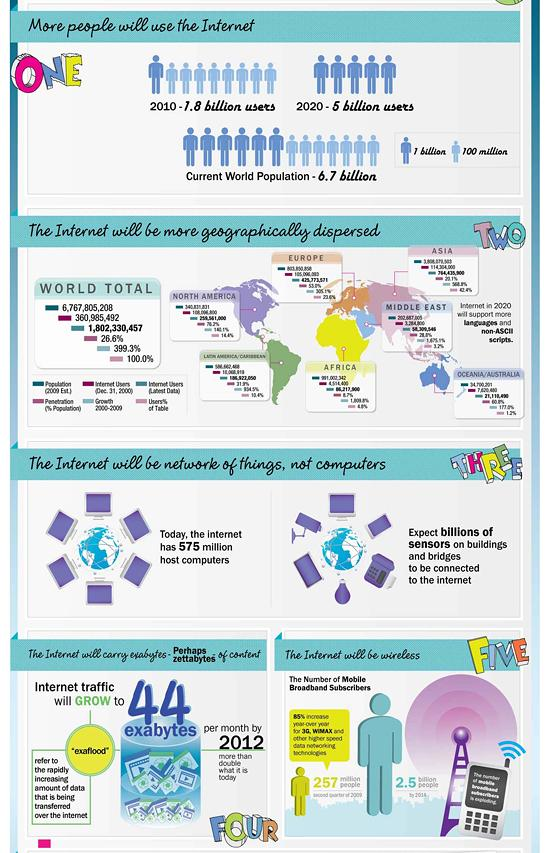Identify some key points in this picture. The last point mentioned about the internet is that it will be wireless. Approximately 1.7 billion people do not use the internet, representing a significant portion of the global population. The number of internet users in 2020 has increased by approximately 3.2 billion when compared to 2010. As of now, there are approximately 575 million host computers connected to the internet. 